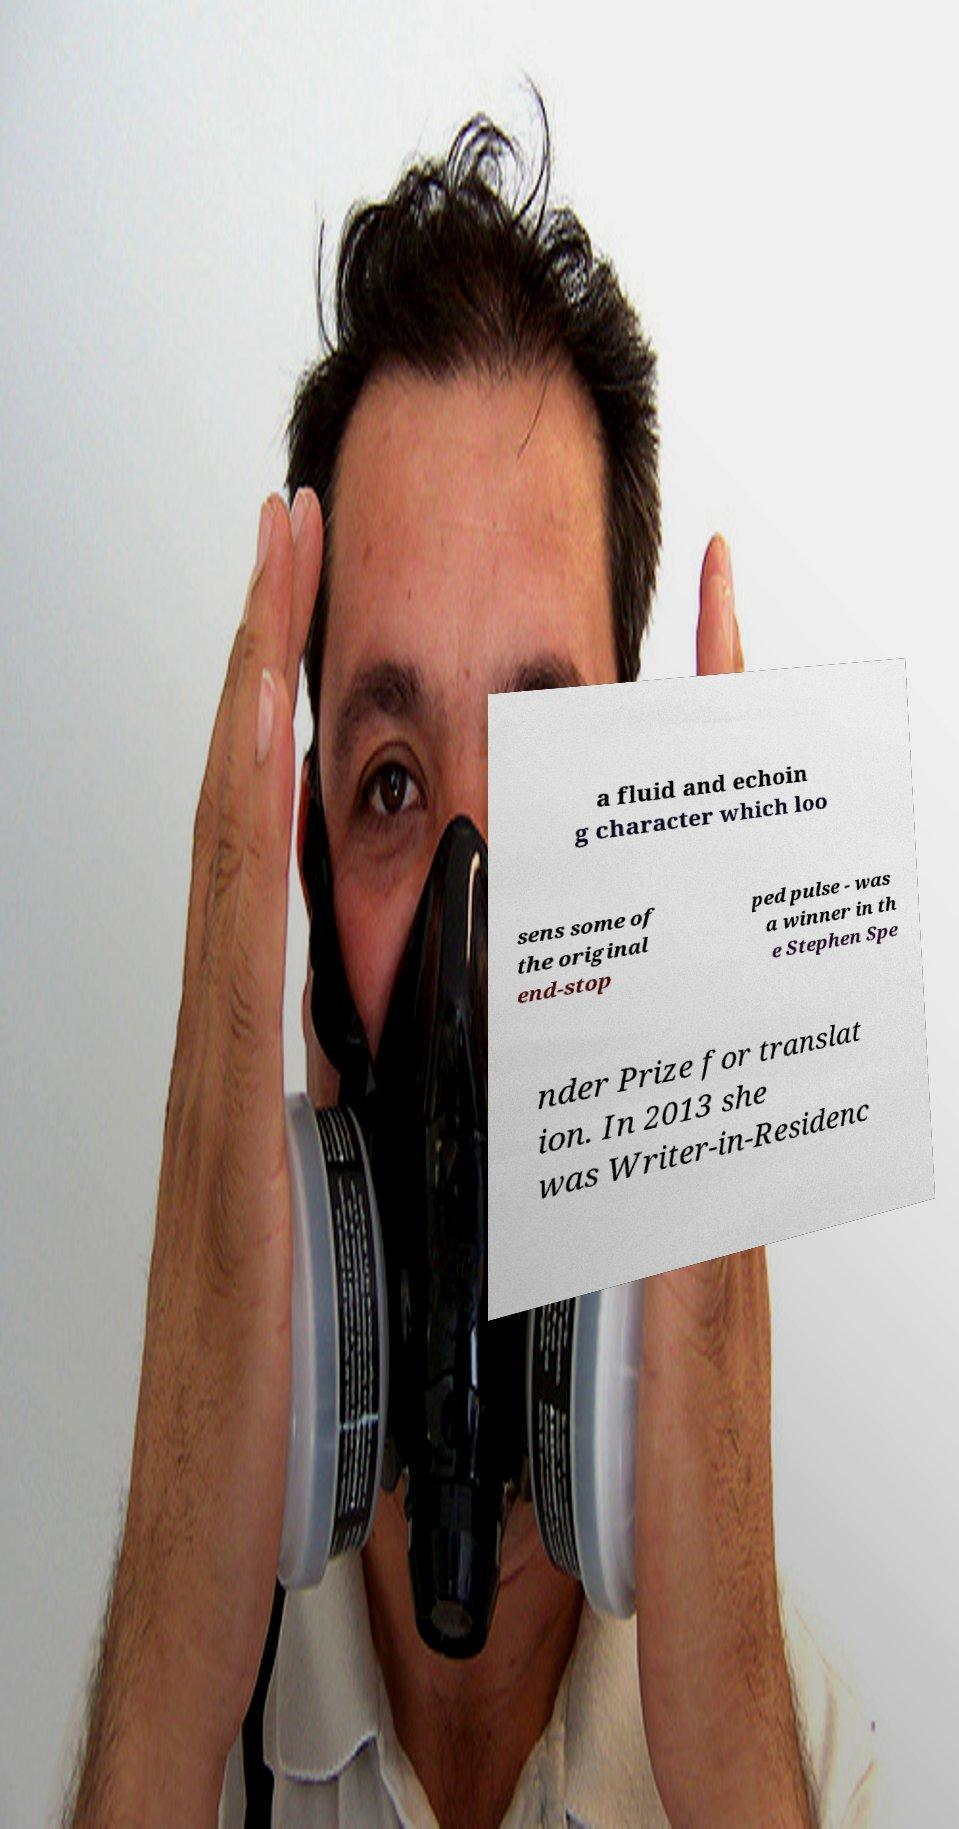What messages or text are displayed in this image? I need them in a readable, typed format. a fluid and echoin g character which loo sens some of the original end-stop ped pulse - was a winner in th e Stephen Spe nder Prize for translat ion. In 2013 she was Writer-in-Residenc 